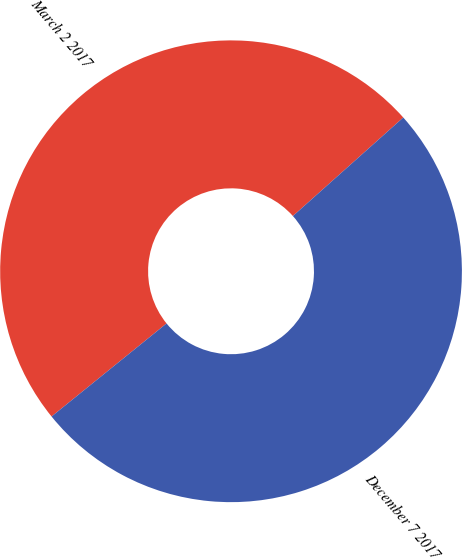<chart> <loc_0><loc_0><loc_500><loc_500><pie_chart><fcel>March 2 2017<fcel>December 7 2017<nl><fcel>49.23%<fcel>50.77%<nl></chart> 